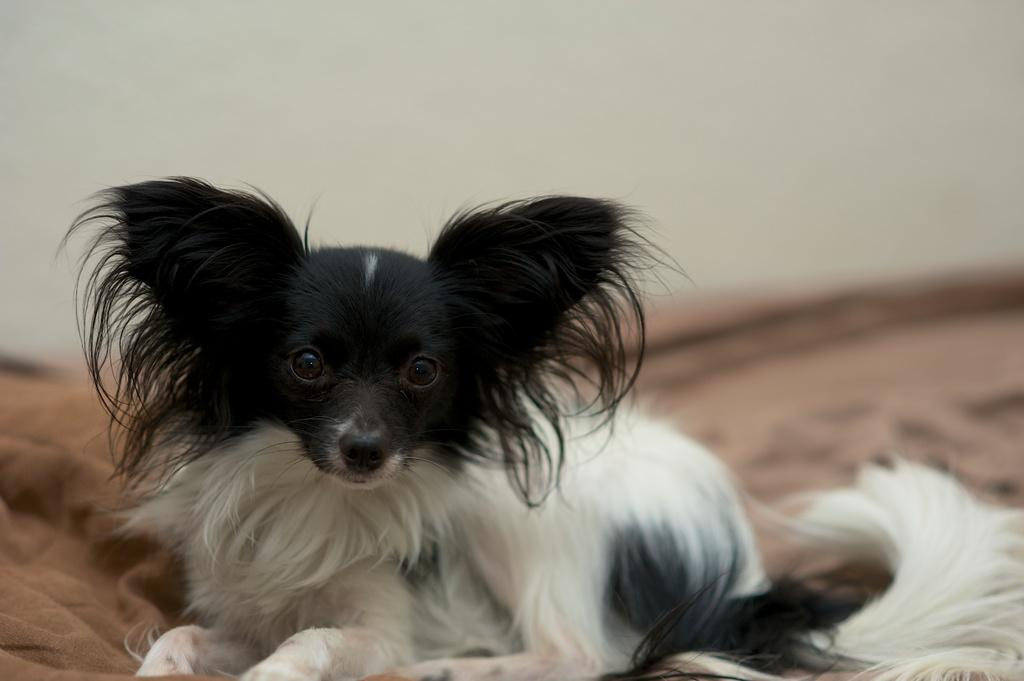What animal is present in the image? There is a dog in the picture. What is the dog sitting on? The dog is sitting on a cloth. Can you describe the background of the image? The background of the image is blurred. What type of poison is the dog holding in its mouth in the image? There is no poison present in the image; the dog is sitting on a cloth. 